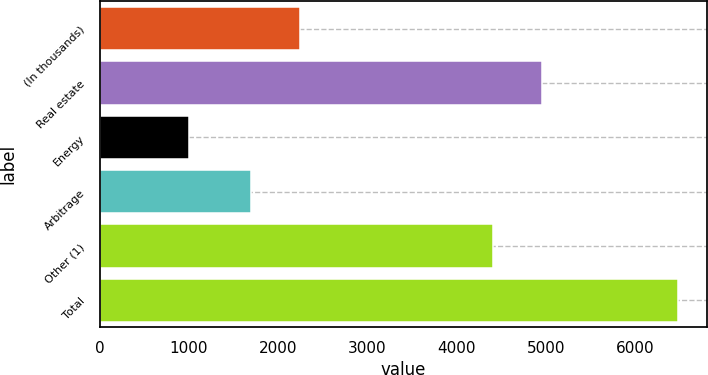Convert chart to OTSL. <chart><loc_0><loc_0><loc_500><loc_500><bar_chart><fcel>(In thousands)<fcel>Real estate<fcel>Energy<fcel>Arbitrage<fcel>Other (1)<fcel>Total<nl><fcel>2240.5<fcel>4951.5<fcel>996<fcel>1692<fcel>4403<fcel>6481<nl></chart> 